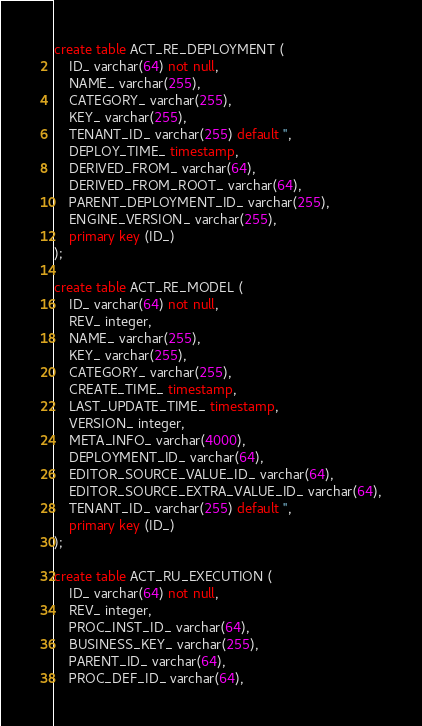<code> <loc_0><loc_0><loc_500><loc_500><_SQL_>create table ACT_RE_DEPLOYMENT (
    ID_ varchar(64) not null,
    NAME_ varchar(255),
    CATEGORY_ varchar(255),
    KEY_ varchar(255),
    TENANT_ID_ varchar(255) default '',
    DEPLOY_TIME_ timestamp,
    DERIVED_FROM_ varchar(64),
    DERIVED_FROM_ROOT_ varchar(64),
    PARENT_DEPLOYMENT_ID_ varchar(255),
    ENGINE_VERSION_ varchar(255),
    primary key (ID_)
);

create table ACT_RE_MODEL (
    ID_ varchar(64) not null,
    REV_ integer,
    NAME_ varchar(255),
    KEY_ varchar(255),
    CATEGORY_ varchar(255),
    CREATE_TIME_ timestamp,
    LAST_UPDATE_TIME_ timestamp,
    VERSION_ integer,
    META_INFO_ varchar(4000),
    DEPLOYMENT_ID_ varchar(64),
    EDITOR_SOURCE_VALUE_ID_ varchar(64),
    EDITOR_SOURCE_EXTRA_VALUE_ID_ varchar(64),
    TENANT_ID_ varchar(255) default '',
    primary key (ID_)
);

create table ACT_RU_EXECUTION (
    ID_ varchar(64) not null,
    REV_ integer,
    PROC_INST_ID_ varchar(64),
    BUSINESS_KEY_ varchar(255),
    PARENT_ID_ varchar(64),
    PROC_DEF_ID_ varchar(64),</code> 